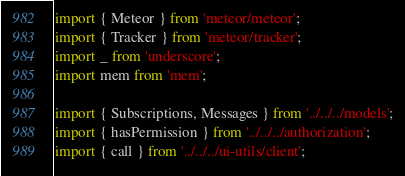<code> <loc_0><loc_0><loc_500><loc_500><_JavaScript_>import { Meteor } from 'meteor/meteor';
import { Tracker } from 'meteor/tracker';
import _ from 'underscore';
import mem from 'mem';

import { Subscriptions, Messages } from '../../../models';
import { hasPermission } from '../../../authorization';
import { call } from '../../../ui-utils/client';
</code> 